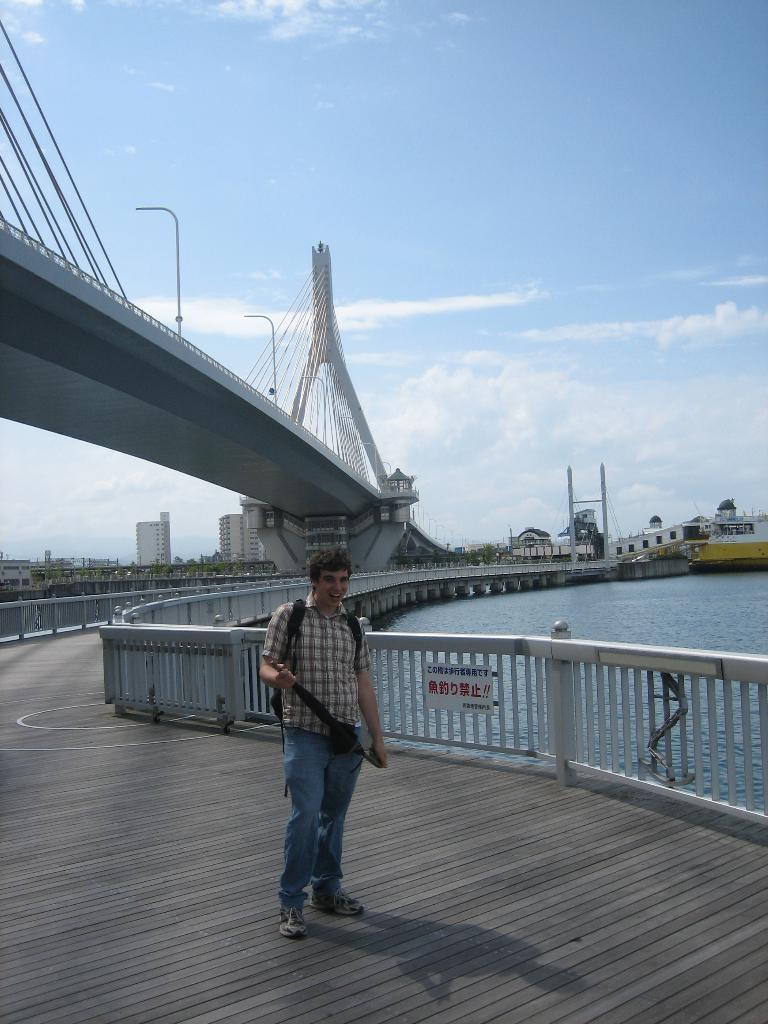What is the main subject in the foreground of the image? There is a man standing on the path in the foreground of the image. What can be seen in the background of the image? There is a railing of a bridge, a flyover, water, buildings, and the sky visible in the background of the image. Can you describe the sky in the image? The sky is visible in the background of the image, and there is a cloud visible in the sky. What type of chair is the duck sitting on in the image? There is no duck or chair present in the image. Is the carpenter working on any projects in the image? There is no carpenter or any indication of a project being worked on in the image. 